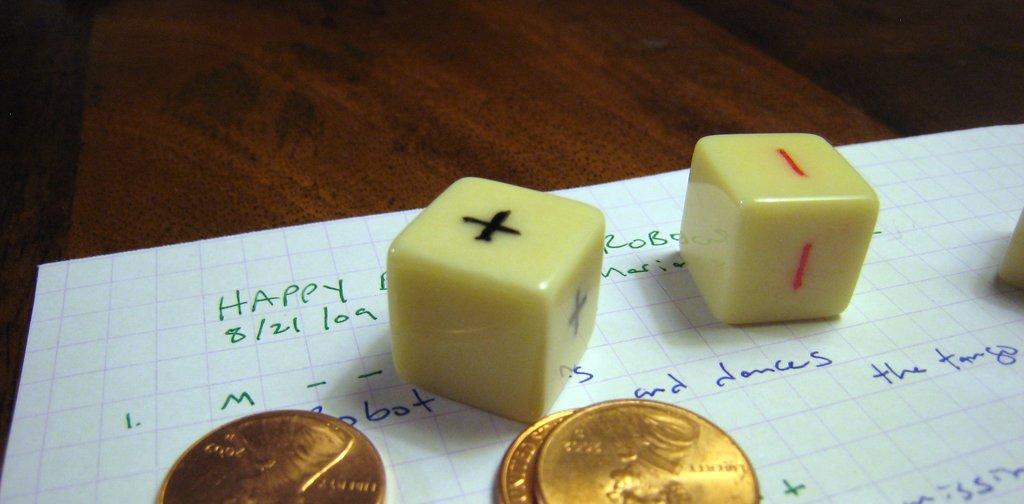What sate is on this paper?
Ensure brevity in your answer.  Unanswerable. What is the first word on the upper left?
Make the answer very short. Happy. 